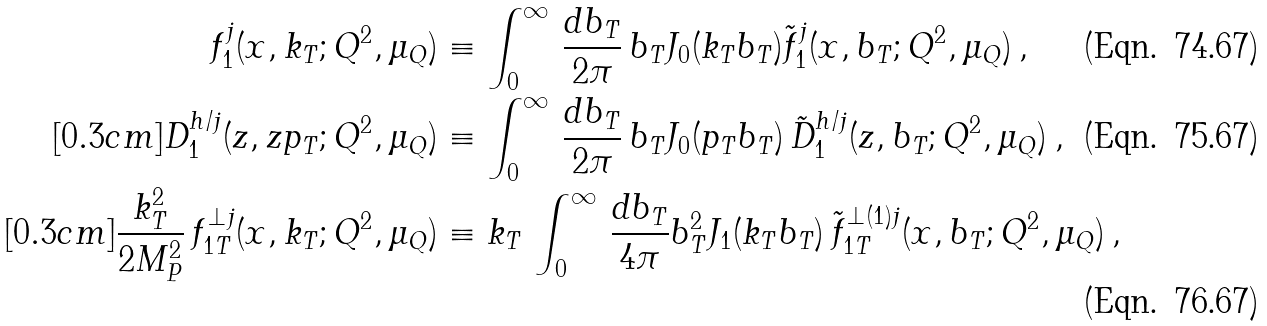Convert formula to latex. <formula><loc_0><loc_0><loc_500><loc_500>f _ { 1 } ^ { j } ( x , k _ { T } ; Q ^ { 2 } , \mu _ { Q } ) & \equiv \int _ { 0 } ^ { \infty } \, \frac { d b _ { T } } { 2 \pi } \, b _ { T } J _ { 0 } ( k _ { T } b _ { T } ) \tilde { f } _ { 1 } ^ { j } ( x , b _ { T } ; Q ^ { 2 } , \mu _ { Q } ) \, , \\ [ 0 . 3 c m ] D _ { 1 } ^ { h / j } ( z , z p _ { T } ; Q ^ { 2 } , \mu _ { Q } ) & \equiv \int _ { 0 } ^ { \infty } \, \frac { d b _ { T } } { 2 \pi } \, b _ { T } J _ { 0 } ( p _ { T } b _ { T } ) \, \tilde { D } _ { 1 } ^ { h / j } ( z , b _ { T } ; Q ^ { 2 } , \mu _ { Q } ) \, , \\ [ 0 . 3 c m ] \frac { k _ { T } ^ { 2 } } { 2 M _ { P } ^ { 2 } } \, f _ { 1 T } ^ { \perp j } ( x , k _ { T } ; Q ^ { 2 } , \mu _ { Q } ) & \equiv k _ { T } \, \int _ { 0 } ^ { \infty } \, \frac { d b _ { T } } { 4 \pi } b _ { T } ^ { 2 } J _ { 1 } ( k _ { T } b _ { T } ) \, \tilde { f } _ { 1 T } ^ { \perp ( 1 ) j } ( x , b _ { T } ; Q ^ { 2 } , \mu _ { Q } ) \, ,</formula> 